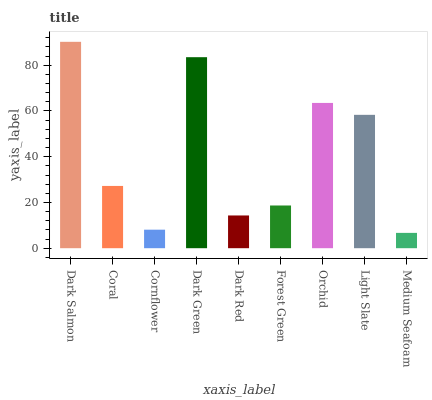Is Medium Seafoam the minimum?
Answer yes or no. Yes. Is Dark Salmon the maximum?
Answer yes or no. Yes. Is Coral the minimum?
Answer yes or no. No. Is Coral the maximum?
Answer yes or no. No. Is Dark Salmon greater than Coral?
Answer yes or no. Yes. Is Coral less than Dark Salmon?
Answer yes or no. Yes. Is Coral greater than Dark Salmon?
Answer yes or no. No. Is Dark Salmon less than Coral?
Answer yes or no. No. Is Coral the high median?
Answer yes or no. Yes. Is Coral the low median?
Answer yes or no. Yes. Is Orchid the high median?
Answer yes or no. No. Is Cornflower the low median?
Answer yes or no. No. 